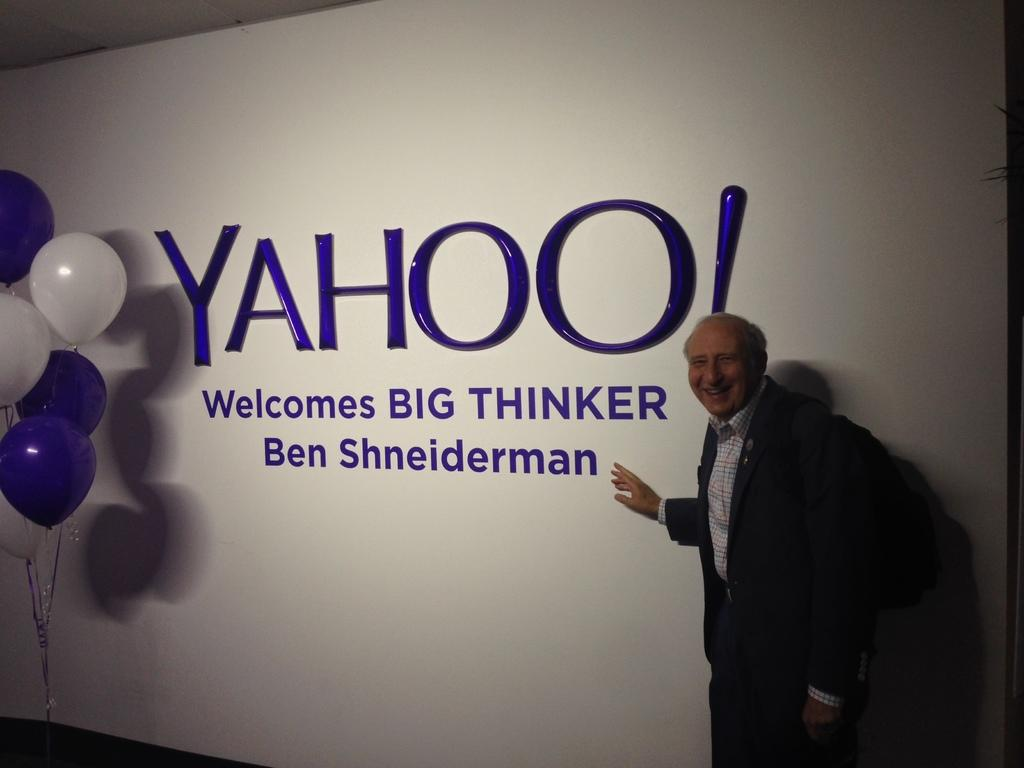Who is the main subject in the image? There is an old man in the image. What is the old man doing in the image? The old man is standing and smiling. What is the old man carrying in the image? The old man is wearing a backpack. What can be seen in the background of the image? There is a banner with text in the background. What decorations are present on the left side of the image? There are balloons with ribbons on the left side of the image. What type of trucks can be seen in the image? There are no trucks present in the image. What language is the old man speaking in the image? The image does not provide any information about the language being spoken. 